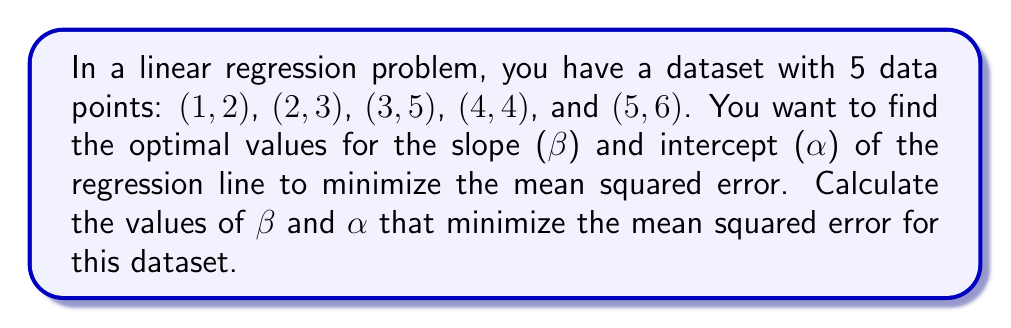Teach me how to tackle this problem. To minimize the mean squared error in a linear regression problem, we need to find the values of β and α that minimize the following function:

$$MSE = \frac{1}{n}\sum_{i=1}^n (y_i - (\alpha + \beta x_i))^2$$

Where n is the number of data points, $y_i$ are the observed values, and $x_i$ are the input values.

To find the minimum, we need to take partial derivatives with respect to α and β and set them to zero:

$$\frac{\partial MSE}{\partial \alpha} = -\frac{2}{n}\sum_{i=1}^n (y_i - (\alpha + \beta x_i)) = 0$$

$$\frac{\partial MSE}{\partial \beta} = -\frac{2}{n}\sum_{i=1}^n x_i(y_i - (\alpha + \beta x_i)) = 0$$

Simplifying these equations leads to the normal equations:

$$\alpha n + \beta \sum_{i=1}^n x_i = \sum_{i=1}^n y_i$$

$$\alpha \sum_{i=1}^n x_i + \beta \sum_{i=1}^n x_i^2 = \sum_{i=1}^n x_i y_i$$

For our dataset:
n = 5
$\sum x_i = 1 + 2 + 3 + 4 + 5 = 15$
$\sum y_i = 2 + 3 + 5 + 4 + 6 = 20$
$\sum x_i^2 = 1^2 + 2^2 + 3^2 + 4^2 + 5^2 = 55$
$\sum x_i y_i = 1(2) + 2(3) + 3(5) + 4(4) + 5(6) = 70$

Substituting these values into the normal equations:

$$5\alpha + 15\beta = 20$$
$$15\alpha + 55\beta = 70$$

Solving this system of equations:

Multiply the first equation by 3 and subtract from the second:

$$15\alpha + 45\beta = 60$$
$$15\alpha + 55\beta = 70$$
$$-10\beta = -10$$
$$\beta = 1$$

Substituting β = 1 into the first equation:

$$5\alpha + 15(1) = 20$$
$$5\alpha = 5$$
$$\alpha = 1$$

Therefore, the optimal values that minimize the mean squared error are β = 1 and α = 1.
Answer: β = 1, α = 1 